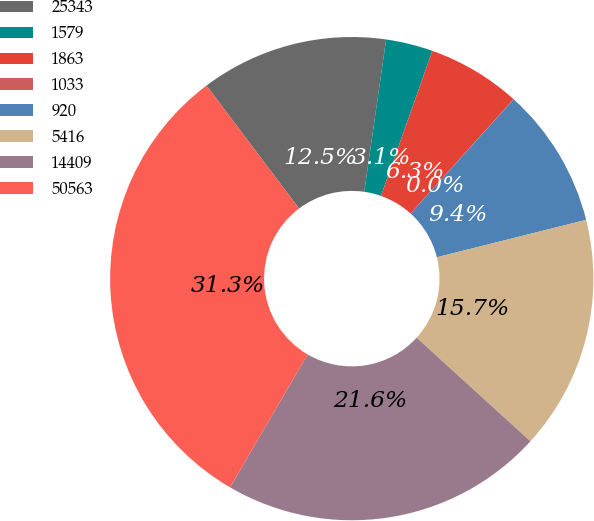Convert chart. <chart><loc_0><loc_0><loc_500><loc_500><pie_chart><fcel>25343<fcel>1579<fcel>1863<fcel>1033<fcel>920<fcel>5416<fcel>14409<fcel>50563<nl><fcel>12.54%<fcel>3.14%<fcel>6.27%<fcel>0.01%<fcel>9.4%<fcel>15.67%<fcel>21.65%<fcel>31.33%<nl></chart> 